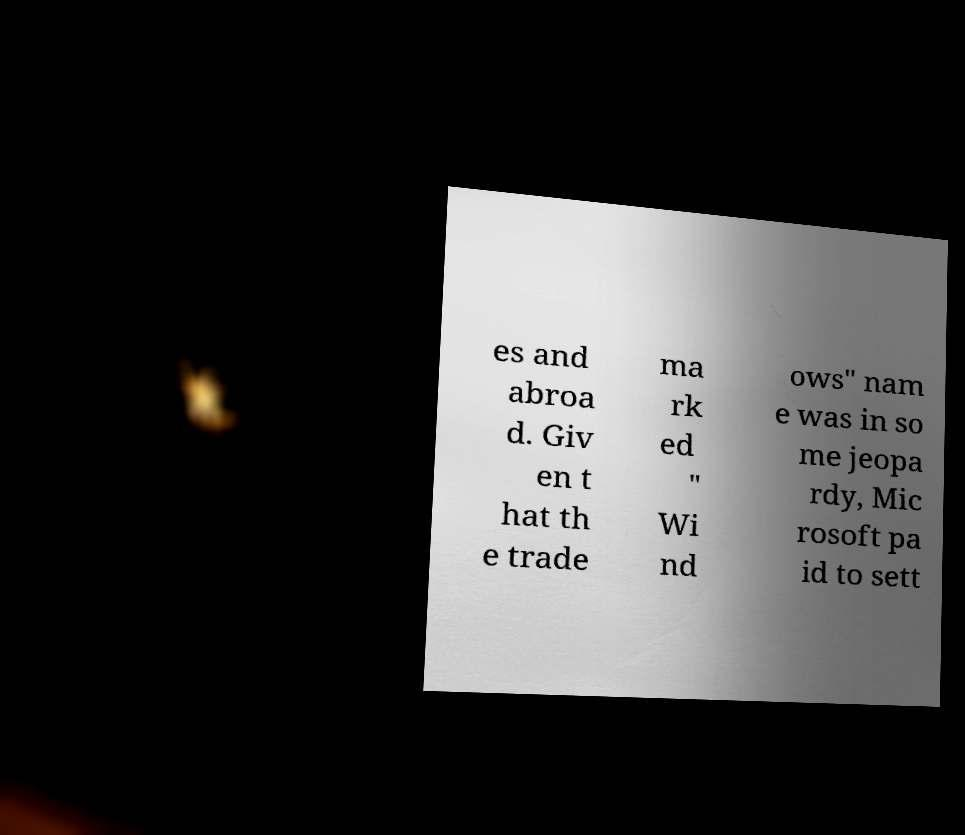Could you assist in decoding the text presented in this image and type it out clearly? es and abroa d. Giv en t hat th e trade ma rk ed " Wi nd ows" nam e was in so me jeopa rdy, Mic rosoft pa id to sett 